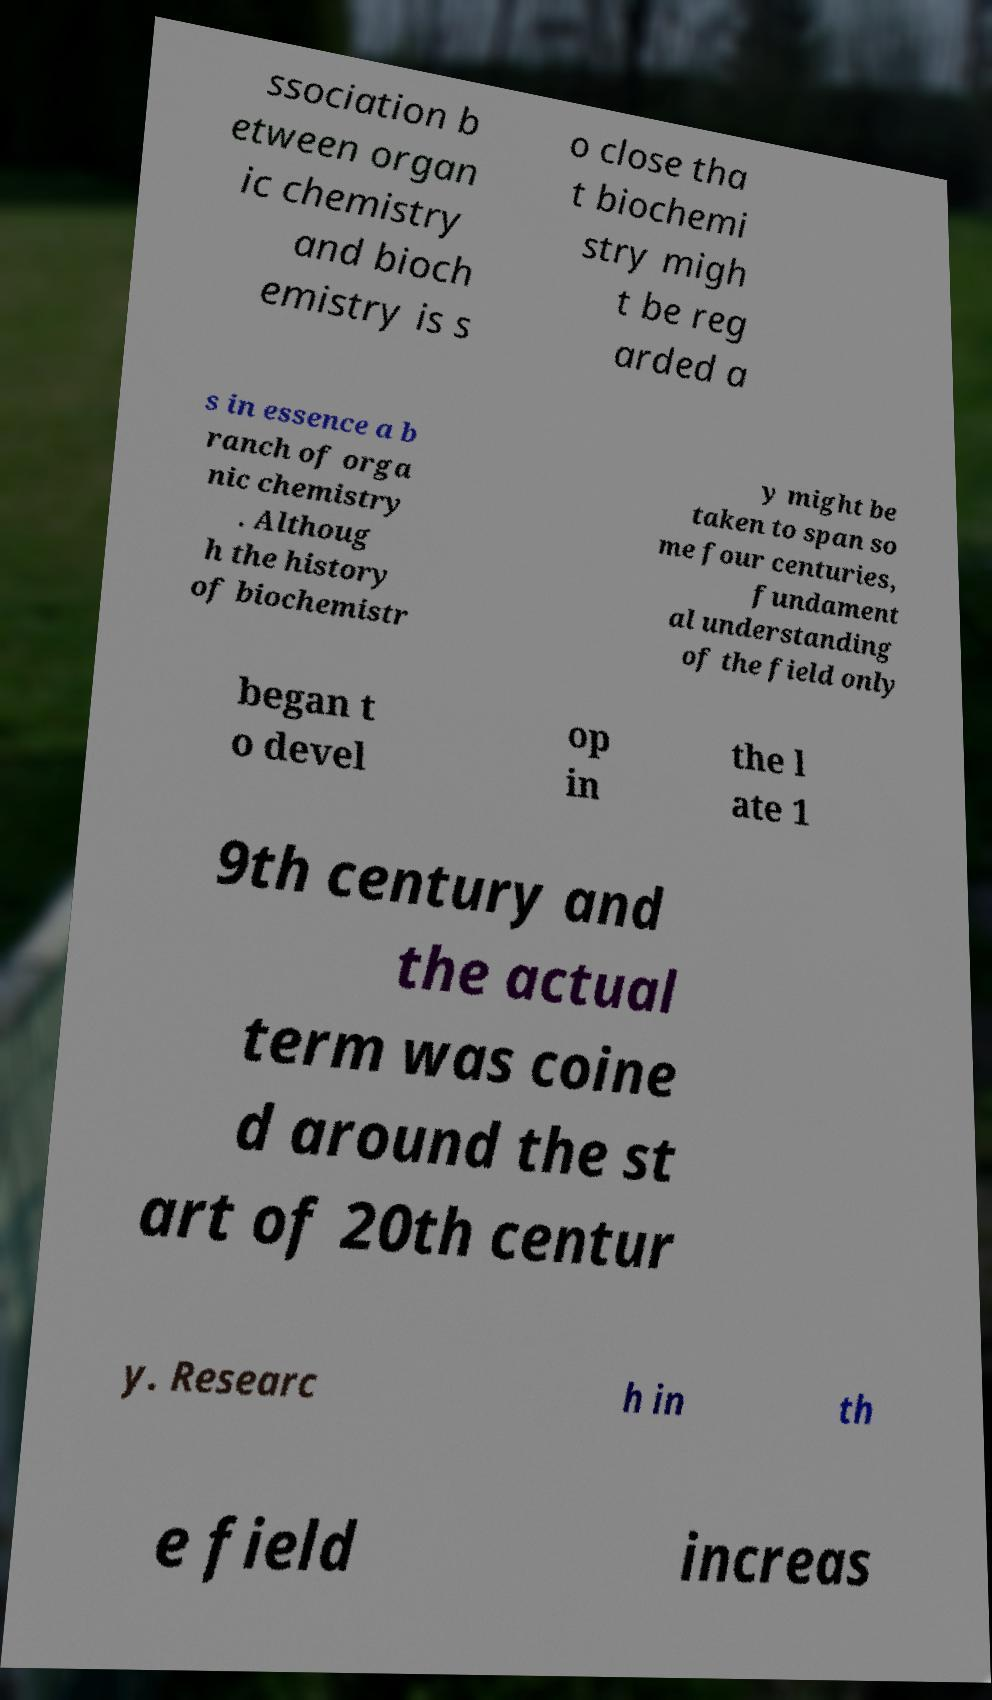Can you read and provide the text displayed in the image?This photo seems to have some interesting text. Can you extract and type it out for me? ssociation b etween organ ic chemistry and bioch emistry is s o close tha t biochemi stry migh t be reg arded a s in essence a b ranch of orga nic chemistry . Althoug h the history of biochemistr y might be taken to span so me four centuries, fundament al understanding of the field only began t o devel op in the l ate 1 9th century and the actual term was coine d around the st art of 20th centur y. Researc h in th e field increas 